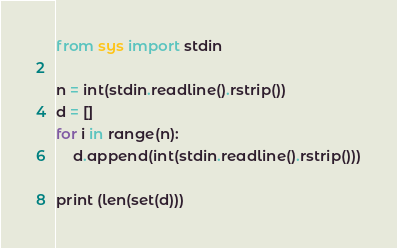Convert code to text. <code><loc_0><loc_0><loc_500><loc_500><_Python_>from sys import stdin

n = int(stdin.readline().rstrip())
d = []
for i in range(n):
    d.append(int(stdin.readline().rstrip()))

print (len(set(d)))






</code> 